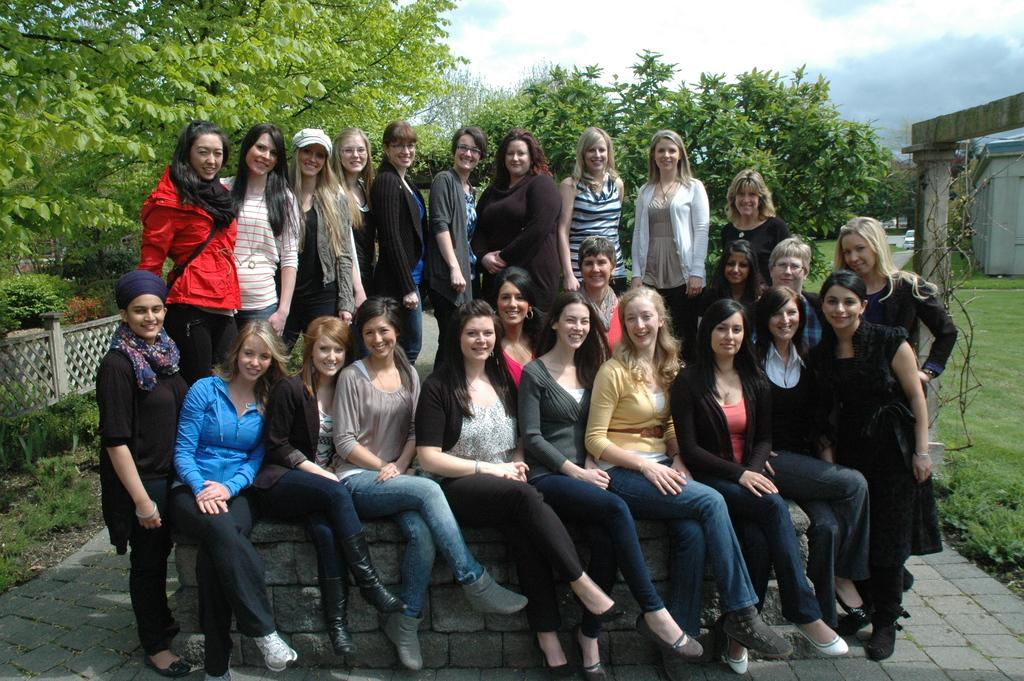Who or what is present in the image? There are people in the image. What are the people doing in the image? The people are posing with smiles and facing the camera. What can be seen in the background of the image? There are trees and the sky visible in the background of the image. What type of yoke is being used by the people in the image? There is no yoke present in the image; it features people posing with smiles and facing the camera. How does the ice affect the people's poses in the image? There is no ice present in the image, so it does not affect the people's poses. 